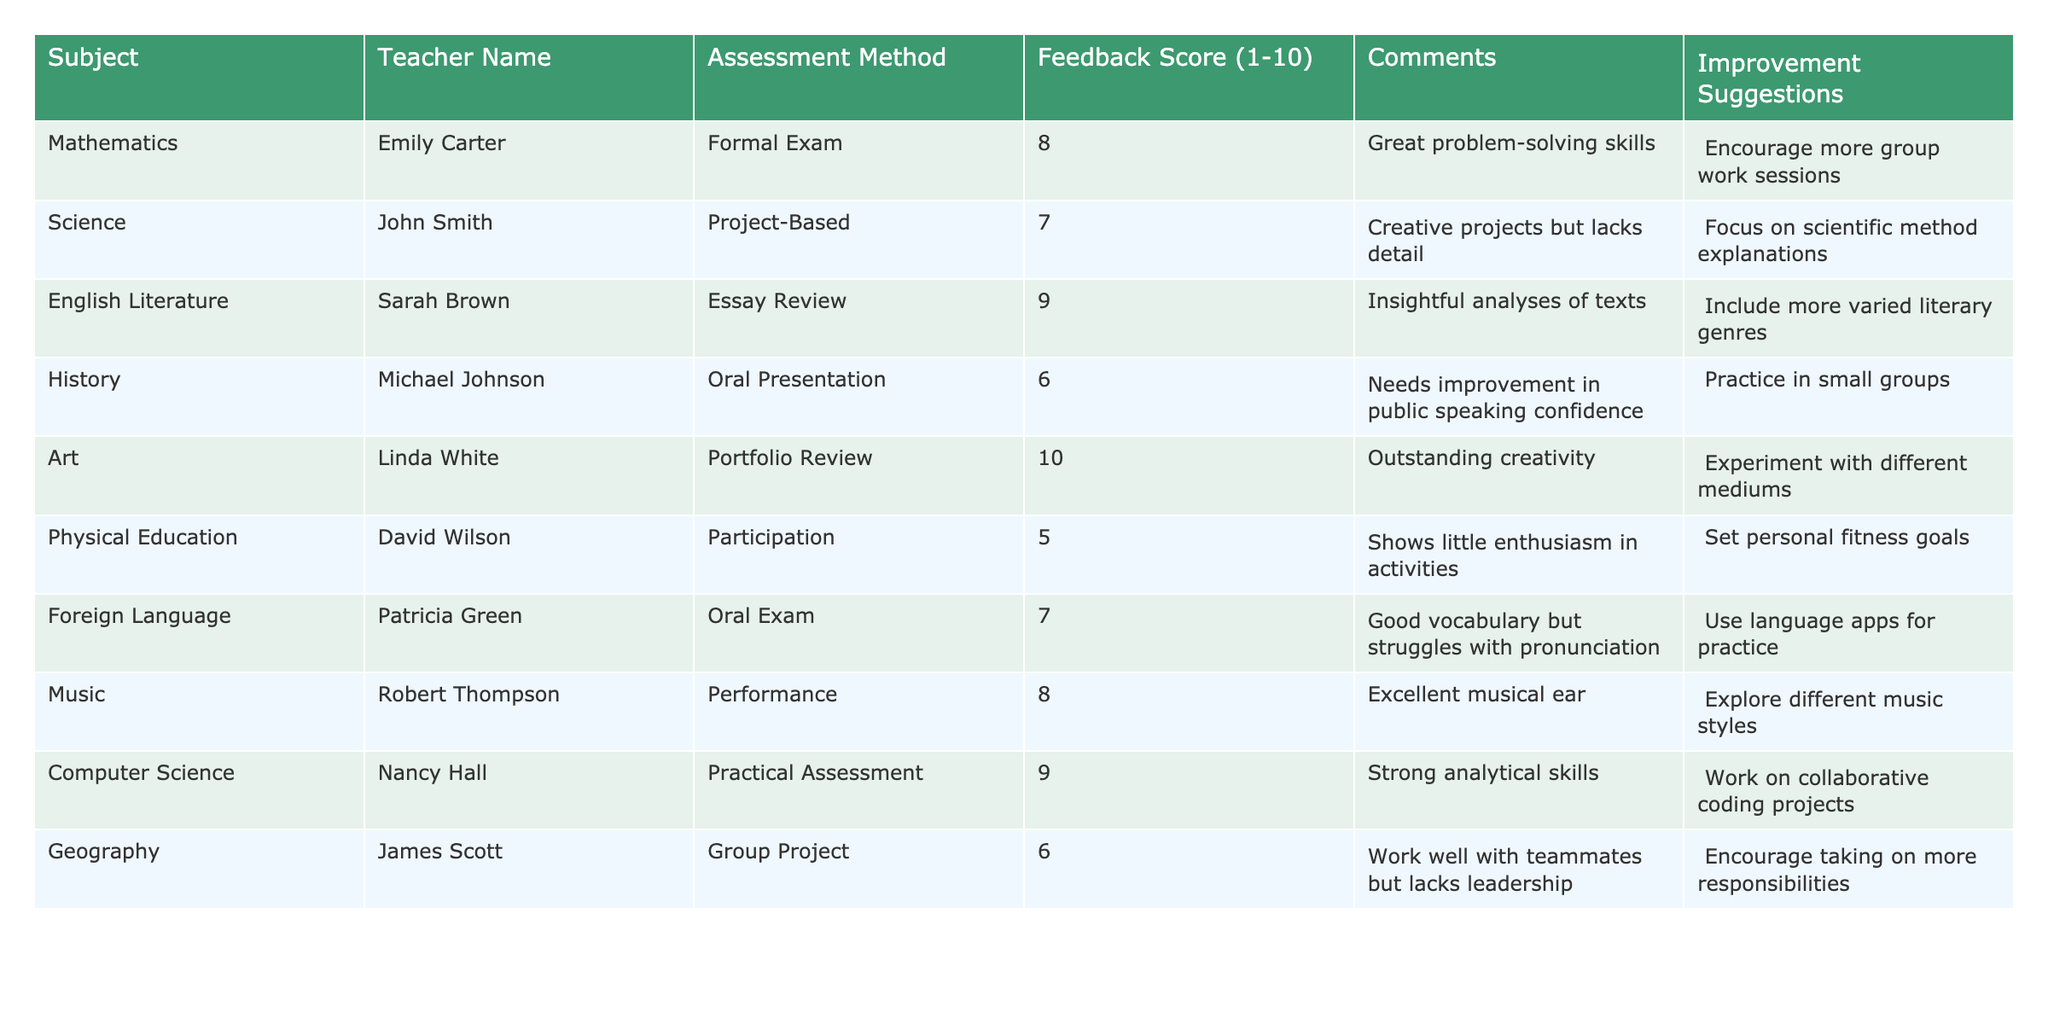What is the highest feedback score in the table? The table lists feedback scores, and the maximum value can be identified by comparing them. The highest score is 10 from Linda White's Art portfolio review.
Answer: 10 Which subject received the lowest feedback score? The lowest feedback score found in the table can be determined by looking at all the scores. The lowest score is 5 for Physical Education from David Wilson's participation assessment.
Answer: Physical Education What is the average feedback score across all subjects? To find the average, add all the feedback scores: (8 + 7 + 9 + 6 + 10 + 5 + 7 + 8 + 9 + 6) = 75. Then, divide by the number of subjects, which is 10. Thus, the average is 75/10 = 7.5.
Answer: 7.5 Is Sarah Brown's feedback score higher than David Wilson's? Sarah Brown received a feedback score of 9, whereas David Wilson received a score of 5. Since 9 is greater than 5, the statement is true.
Answer: Yes How many teachers received a feedback score of 8 or higher? Count the entries in the table where the feedback score is 8 or more: Emily Carter (8), Sarah Brown (9), Linda White (10), Robert Thompson (8), Nancy Hall (9). There are 5 teachers.
Answer: 5 What is the difference between the highest and lowest feedback scores? The highest score is 10 and the lowest score is 5. Therefore, the difference is 10 - 5 = 5.
Answer: 5 Which subject has comments suggesting more group-related activities? The comments for Mathematics suggest encouraging more group work sessions, indicating a focus on group-related activities.
Answer: Mathematics Identify the teacher with the highest feedback score and their assessment method. Linda White received the highest feedback score of 10, and her assessment method was Portfolio Review.
Answer: Linda White, Portfolio Review Are there more subjects with feedback scores above 7 than those at 6 or below? The subjects with feedback scores above 7 are Mathematics (8), English Literature (9), Art (10), Music (8), and Computer Science (9), totaling 5. The subjects with scores at 6 or below are History (6), Physical Education (5), and Geography (6), totaling 3. Since 5 is greater than 3, the statement is true.
Answer: Yes Which two subjects have the same feedback score, and what is that score? Geography and History both received a feedback score of 6.
Answer: 6 